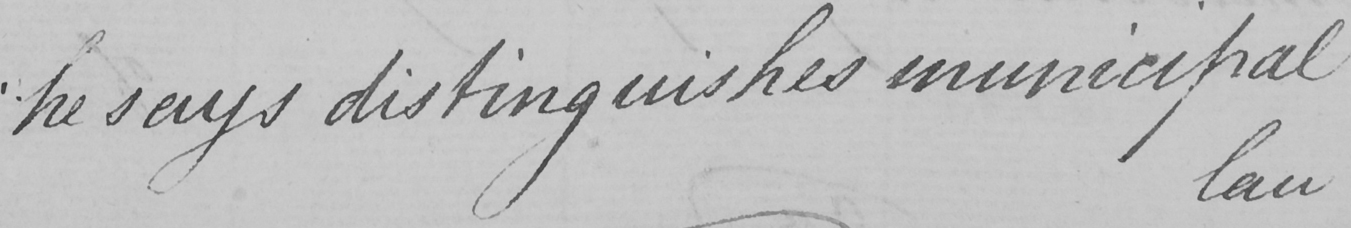What is written in this line of handwriting? " he says distinguishes municipal 